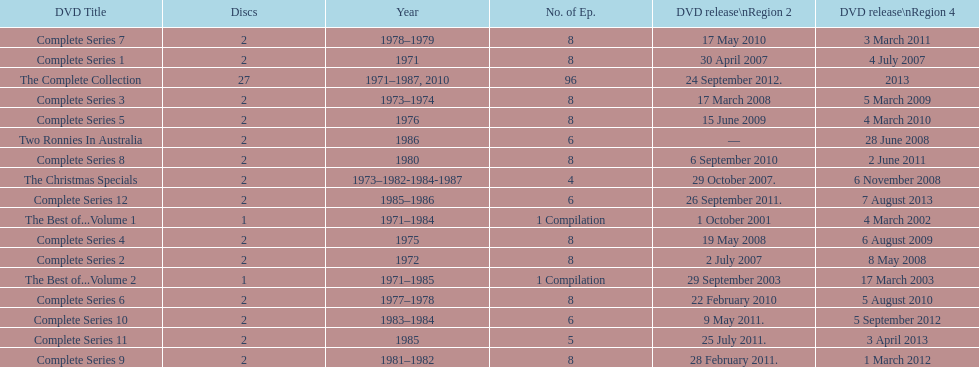Total number of episodes released in region 2 in 2007 20. 